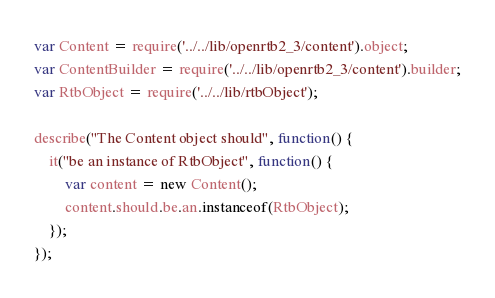Convert code to text. <code><loc_0><loc_0><loc_500><loc_500><_JavaScript_>var Content = require('../../lib/openrtb2_3/content').object;
var ContentBuilder = require('../../lib/openrtb2_3/content').builder;
var RtbObject = require('../../lib/rtbObject');

describe("The Content object should", function() {
	it("be an instance of RtbObject", function() {
		var content = new Content();
		content.should.be.an.instanceof(RtbObject);      
	});
});
</code> 